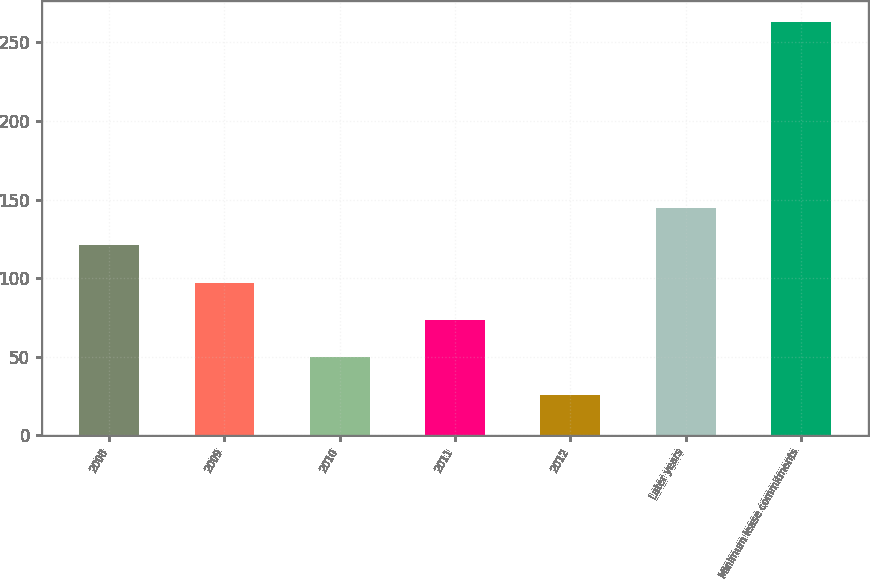<chart> <loc_0><loc_0><loc_500><loc_500><bar_chart><fcel>2008<fcel>2009<fcel>2010<fcel>2011<fcel>2012<fcel>Later years<fcel>Minimum lease commitments<nl><fcel>120.8<fcel>97.1<fcel>49.7<fcel>73.4<fcel>26<fcel>144.5<fcel>263<nl></chart> 